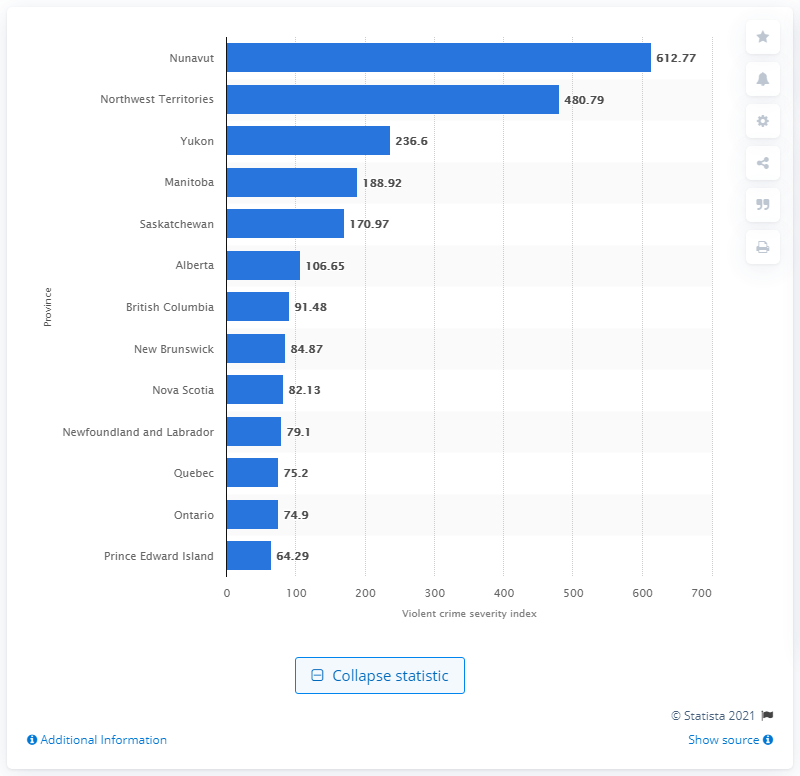Specify some key components in this picture. The violent crime severity index in Nunavut in 2019 was 612.77. 